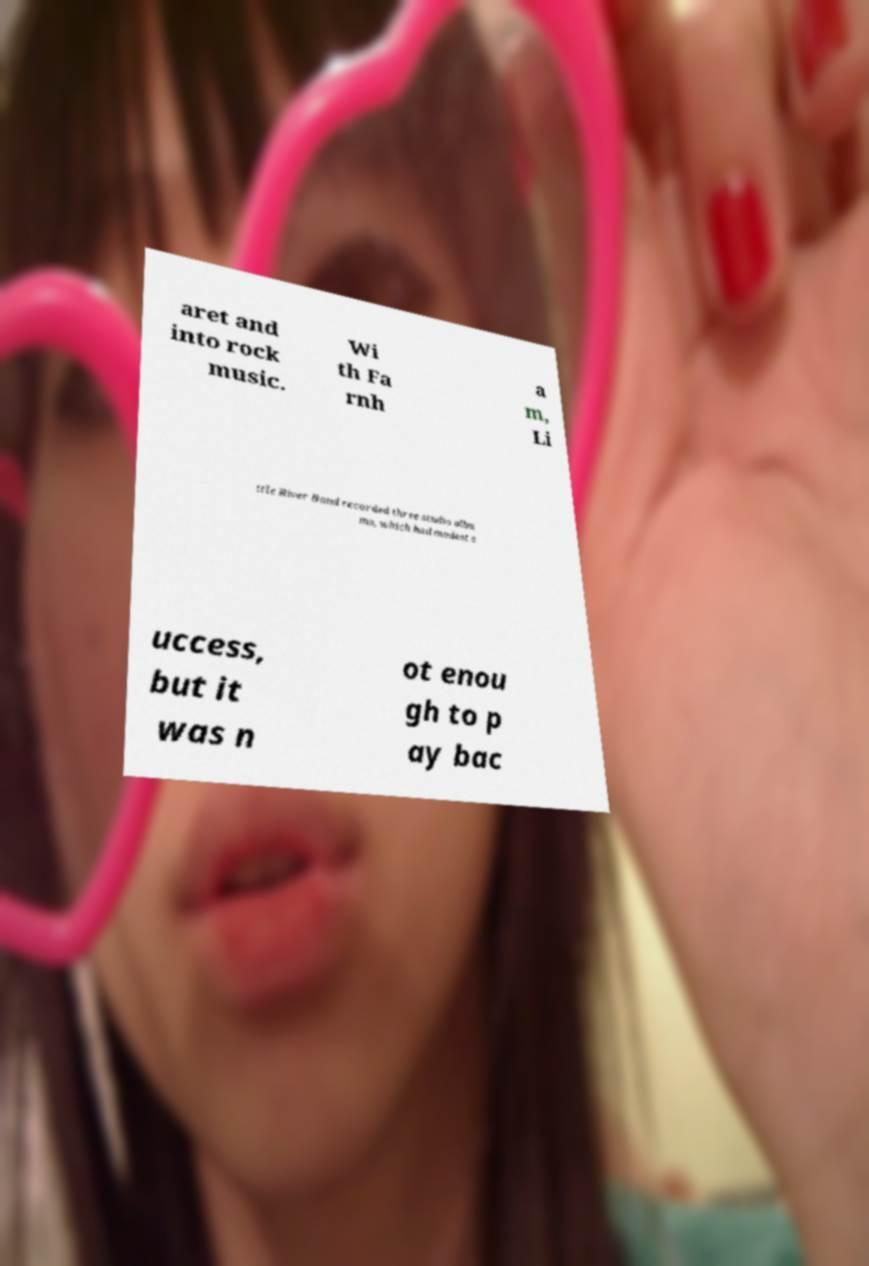What messages or text are displayed in this image? I need them in a readable, typed format. aret and into rock music. Wi th Fa rnh a m, Li ttle River Band recorded three studio albu ms, which had modest s uccess, but it was n ot enou gh to p ay bac 